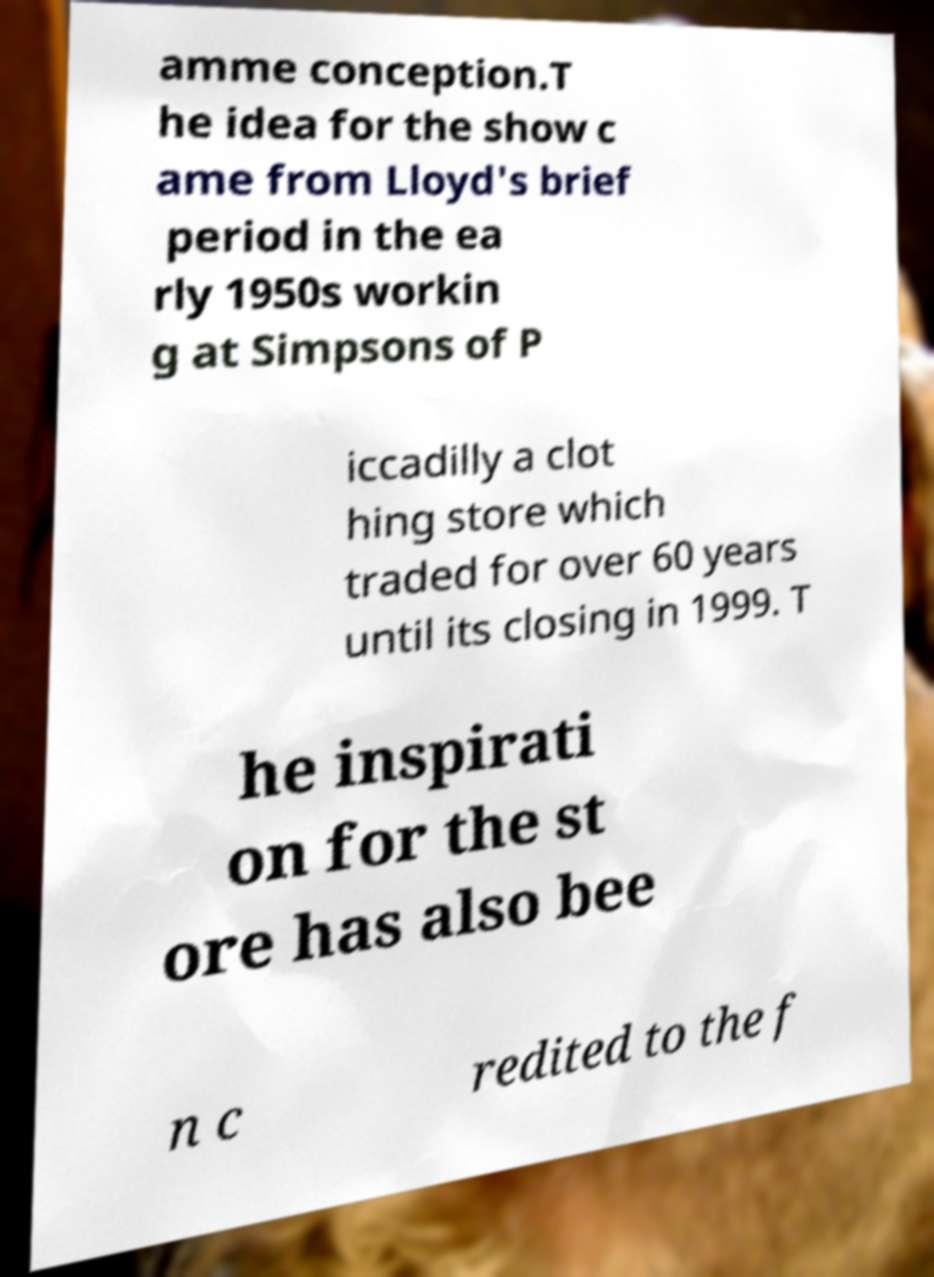Please read and relay the text visible in this image. What does it say? amme conception.T he idea for the show c ame from Lloyd's brief period in the ea rly 1950s workin g at Simpsons of P iccadilly a clot hing store which traded for over 60 years until its closing in 1999. T he inspirati on for the st ore has also bee n c redited to the f 